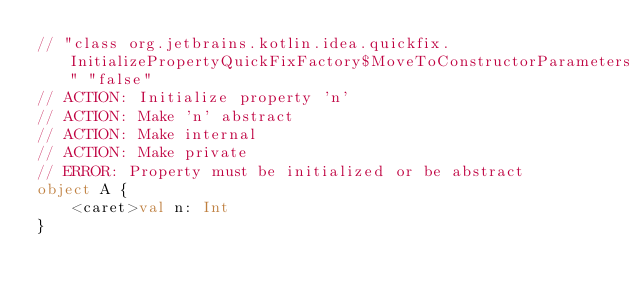Convert code to text. <code><loc_0><loc_0><loc_500><loc_500><_Kotlin_>// "class org.jetbrains.kotlin.idea.quickfix.InitializePropertyQuickFixFactory$MoveToConstructorParameters" "false"
// ACTION: Initialize property 'n'
// ACTION: Make 'n' abstract
// ACTION: Make internal
// ACTION: Make private
// ERROR: Property must be initialized or be abstract
object A {
    <caret>val n: Int
}</code> 